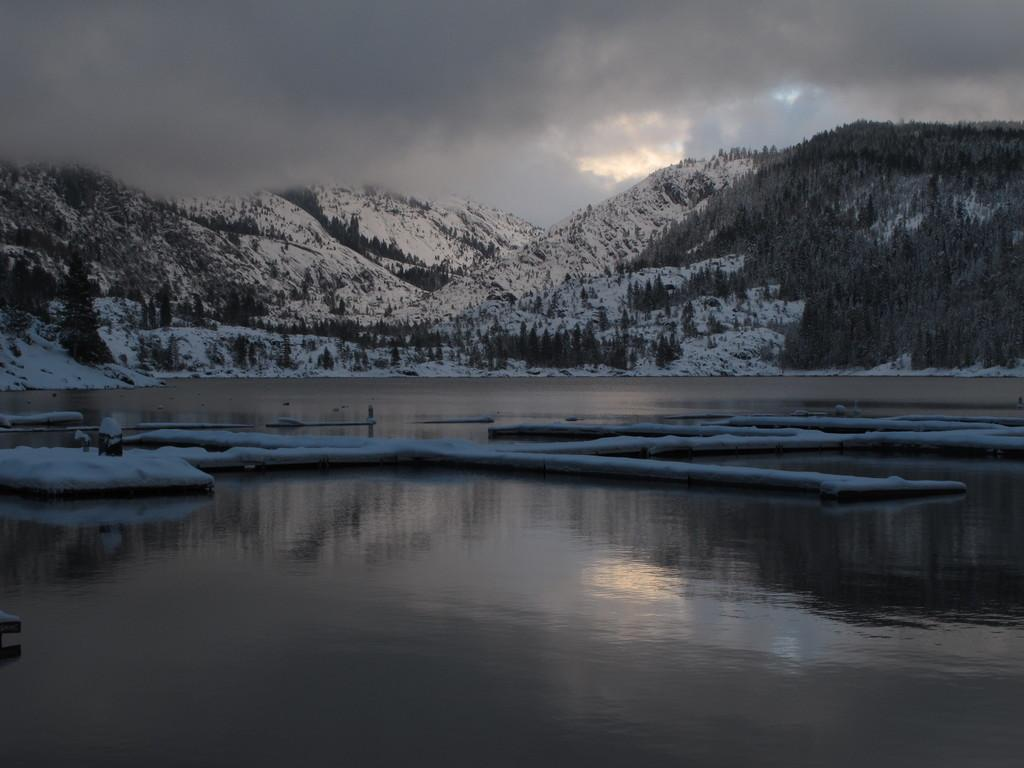What type of body of water is in the image? There is a lake in the image. What can be seen behind the lake? Hills are visible behind the lake. How are the hills characterized? The hills are covered in snow. What type of vegetation is present in the image? Trees are present in the image. What is visible in the sky in the image? The sky is visible in the image, and clouds are present. Where is the station located in the image? There is no station present in the image. How many bikes can be seen near the trees in the image? There are no bikes visible in the image. 